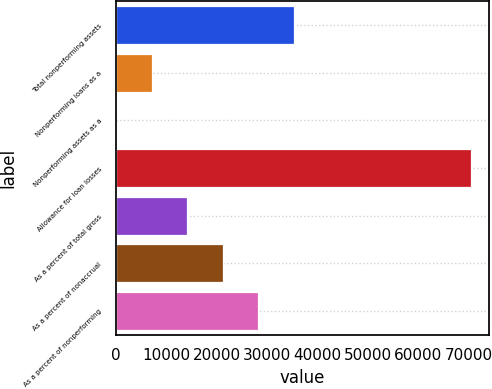Convert chart. <chart><loc_0><loc_0><loc_500><loc_500><bar_chart><fcel>Total nonperforming assets<fcel>Nonperforming loans as a<fcel>Nonperforming assets as a<fcel>Allowance for loan losses<fcel>As a percent of total gross<fcel>As a percent of nonaccrual<fcel>As a percent of nonperforming<nl><fcel>35250.2<fcel>7050.45<fcel>0.5<fcel>70500<fcel>14100.4<fcel>21150.3<fcel>28200.3<nl></chart> 